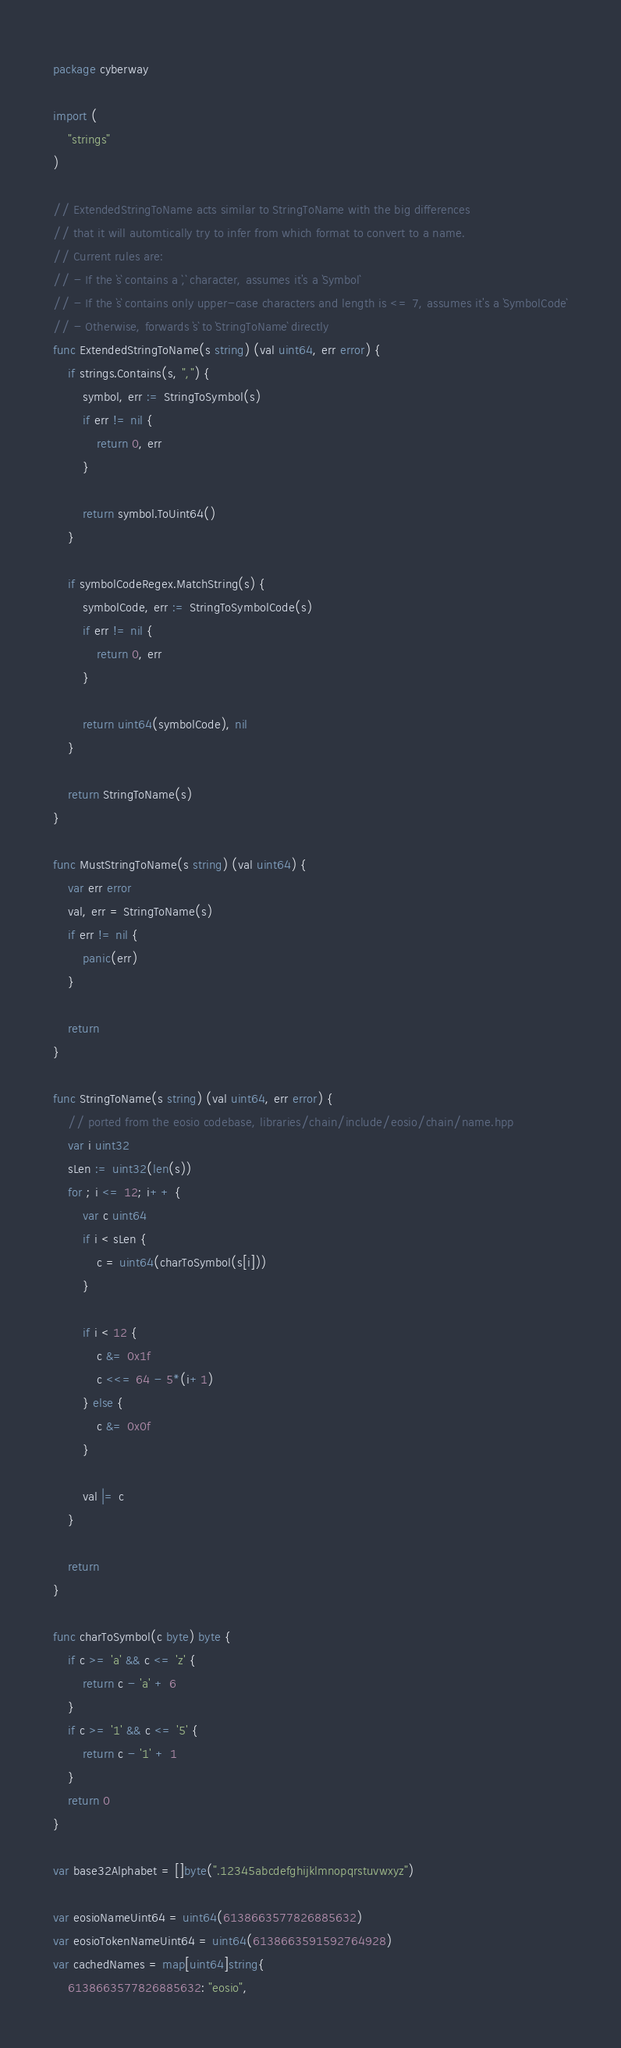<code> <loc_0><loc_0><loc_500><loc_500><_Go_>package cyberway

import (
	"strings"
)

// ExtendedStringToName acts similar to StringToName with the big differences
// that it will automtically try to infer from which format to convert to a name.
// Current rules are:
// - If the `s` contains a `,` character, assumes it's a `Symbol`
// - If the `s` contains only upper-case characters and length is <= 7, assumes it's a `SymbolCode`
// - Otherwise, forwards `s` to `StringToName` directly
func ExtendedStringToName(s string) (val uint64, err error) {
	if strings.Contains(s, ",") {
		symbol, err := StringToSymbol(s)
		if err != nil {
			return 0, err
		}

		return symbol.ToUint64()
	}

	if symbolCodeRegex.MatchString(s) {
		symbolCode, err := StringToSymbolCode(s)
		if err != nil {
			return 0, err
		}

		return uint64(symbolCode), nil
	}

	return StringToName(s)
}

func MustStringToName(s string) (val uint64) {
	var err error
	val, err = StringToName(s)
	if err != nil {
		panic(err)
	}

	return
}

func StringToName(s string) (val uint64, err error) {
	// ported from the eosio codebase, libraries/chain/include/eosio/chain/name.hpp
	var i uint32
	sLen := uint32(len(s))
	for ; i <= 12; i++ {
		var c uint64
		if i < sLen {
			c = uint64(charToSymbol(s[i]))
		}

		if i < 12 {
			c &= 0x1f
			c <<= 64 - 5*(i+1)
		} else {
			c &= 0x0f
		}

		val |= c
	}

	return
}

func charToSymbol(c byte) byte {
	if c >= 'a' && c <= 'z' {
		return c - 'a' + 6
	}
	if c >= '1' && c <= '5' {
		return c - '1' + 1
	}
	return 0
}

var base32Alphabet = []byte(".12345abcdefghijklmnopqrstuvwxyz")

var eosioNameUint64 = uint64(6138663577826885632)
var eosioTokenNameUint64 = uint64(6138663591592764928)
var cachedNames = map[uint64]string{
	6138663577826885632: "eosio",</code> 